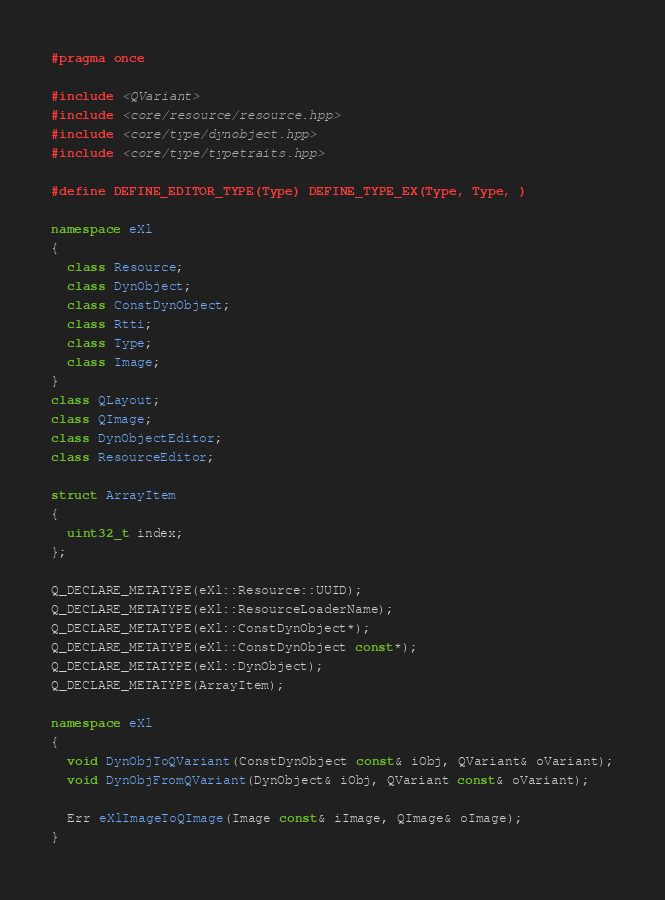<code> <loc_0><loc_0><loc_500><loc_500><_C++_>#pragma once

#include <QVariant>
#include <core/resource/resource.hpp>
#include <core/type/dynobject.hpp>
#include <core/type/typetraits.hpp>

#define DEFINE_EDITOR_TYPE(Type) DEFINE_TYPE_EX(Type, Type, )

namespace eXl
{
  class Resource;
  class DynObject;
  class ConstDynObject;
  class Rtti;
  class Type;
  class Image;
}
class QLayout;
class QImage;
class DynObjectEditor;
class ResourceEditor;

struct ArrayItem
{
  uint32_t index;
};

Q_DECLARE_METATYPE(eXl::Resource::UUID);
Q_DECLARE_METATYPE(eXl::ResourceLoaderName);
Q_DECLARE_METATYPE(eXl::ConstDynObject*);
Q_DECLARE_METATYPE(eXl::ConstDynObject const*);
Q_DECLARE_METATYPE(eXl::DynObject);
Q_DECLARE_METATYPE(ArrayItem);

namespace eXl
{
  void DynObjToQVariant(ConstDynObject const& iObj, QVariant& oVariant);
  void DynObjFromQVariant(DynObject& iObj, QVariant const& oVariant);

  Err eXlImageToQImage(Image const& iImage, QImage& oImage);
}

</code> 